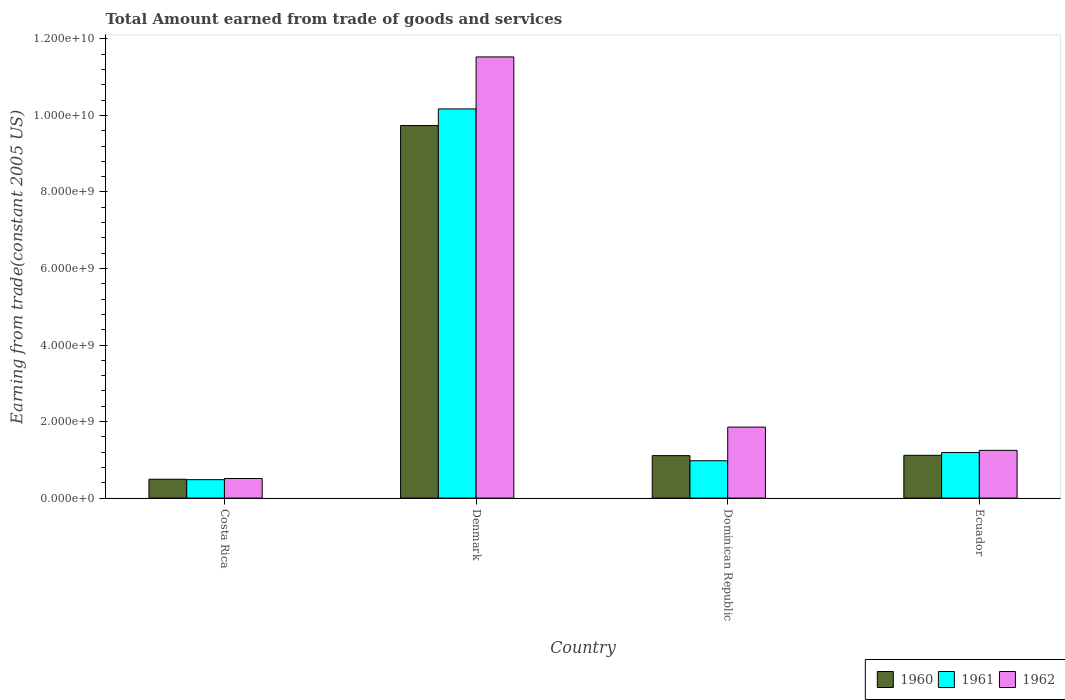How many different coloured bars are there?
Give a very brief answer. 3. Are the number of bars on each tick of the X-axis equal?
Your answer should be very brief. Yes. How many bars are there on the 2nd tick from the right?
Keep it short and to the point. 3. What is the total amount earned by trading goods and services in 1962 in Costa Rica?
Offer a terse response. 5.12e+08. Across all countries, what is the maximum total amount earned by trading goods and services in 1960?
Offer a terse response. 9.74e+09. Across all countries, what is the minimum total amount earned by trading goods and services in 1960?
Provide a succinct answer. 4.92e+08. What is the total total amount earned by trading goods and services in 1962 in the graph?
Ensure brevity in your answer.  1.51e+1. What is the difference between the total amount earned by trading goods and services in 1960 in Denmark and that in Ecuador?
Your response must be concise. 8.62e+09. What is the difference between the total amount earned by trading goods and services in 1960 in Ecuador and the total amount earned by trading goods and services in 1962 in Costa Rica?
Your answer should be very brief. 6.06e+08. What is the average total amount earned by trading goods and services in 1961 per country?
Your response must be concise. 3.20e+09. What is the difference between the total amount earned by trading goods and services of/in 1961 and total amount earned by trading goods and services of/in 1960 in Ecuador?
Provide a short and direct response. 7.24e+07. What is the ratio of the total amount earned by trading goods and services in 1960 in Dominican Republic to that in Ecuador?
Offer a terse response. 0.99. What is the difference between the highest and the second highest total amount earned by trading goods and services in 1962?
Keep it short and to the point. 9.67e+09. What is the difference between the highest and the lowest total amount earned by trading goods and services in 1960?
Provide a short and direct response. 9.24e+09. In how many countries, is the total amount earned by trading goods and services in 1962 greater than the average total amount earned by trading goods and services in 1962 taken over all countries?
Your answer should be very brief. 1. Is the sum of the total amount earned by trading goods and services in 1960 in Denmark and Ecuador greater than the maximum total amount earned by trading goods and services in 1962 across all countries?
Keep it short and to the point. No. What does the 1st bar from the right in Costa Rica represents?
Keep it short and to the point. 1962. Is it the case that in every country, the sum of the total amount earned by trading goods and services in 1962 and total amount earned by trading goods and services in 1961 is greater than the total amount earned by trading goods and services in 1960?
Ensure brevity in your answer.  Yes. How many countries are there in the graph?
Your response must be concise. 4. What is the difference between two consecutive major ticks on the Y-axis?
Your answer should be very brief. 2.00e+09. Does the graph contain grids?
Your response must be concise. No. How are the legend labels stacked?
Your answer should be compact. Horizontal. What is the title of the graph?
Your response must be concise. Total Amount earned from trade of goods and services. Does "2007" appear as one of the legend labels in the graph?
Give a very brief answer. No. What is the label or title of the X-axis?
Offer a very short reply. Country. What is the label or title of the Y-axis?
Your answer should be compact. Earning from trade(constant 2005 US). What is the Earning from trade(constant 2005 US) of 1960 in Costa Rica?
Your answer should be very brief. 4.92e+08. What is the Earning from trade(constant 2005 US) of 1961 in Costa Rica?
Provide a short and direct response. 4.81e+08. What is the Earning from trade(constant 2005 US) of 1962 in Costa Rica?
Make the answer very short. 5.12e+08. What is the Earning from trade(constant 2005 US) in 1960 in Denmark?
Make the answer very short. 9.74e+09. What is the Earning from trade(constant 2005 US) of 1961 in Denmark?
Keep it short and to the point. 1.02e+1. What is the Earning from trade(constant 2005 US) in 1962 in Denmark?
Give a very brief answer. 1.15e+1. What is the Earning from trade(constant 2005 US) of 1960 in Dominican Republic?
Give a very brief answer. 1.11e+09. What is the Earning from trade(constant 2005 US) of 1961 in Dominican Republic?
Make the answer very short. 9.76e+08. What is the Earning from trade(constant 2005 US) of 1962 in Dominican Republic?
Offer a very short reply. 1.86e+09. What is the Earning from trade(constant 2005 US) in 1960 in Ecuador?
Your response must be concise. 1.12e+09. What is the Earning from trade(constant 2005 US) of 1961 in Ecuador?
Your answer should be very brief. 1.19e+09. What is the Earning from trade(constant 2005 US) in 1962 in Ecuador?
Ensure brevity in your answer.  1.25e+09. Across all countries, what is the maximum Earning from trade(constant 2005 US) in 1960?
Offer a very short reply. 9.74e+09. Across all countries, what is the maximum Earning from trade(constant 2005 US) in 1961?
Offer a very short reply. 1.02e+1. Across all countries, what is the maximum Earning from trade(constant 2005 US) in 1962?
Your response must be concise. 1.15e+1. Across all countries, what is the minimum Earning from trade(constant 2005 US) in 1960?
Keep it short and to the point. 4.92e+08. Across all countries, what is the minimum Earning from trade(constant 2005 US) of 1961?
Offer a terse response. 4.81e+08. Across all countries, what is the minimum Earning from trade(constant 2005 US) in 1962?
Your answer should be very brief. 5.12e+08. What is the total Earning from trade(constant 2005 US) of 1960 in the graph?
Make the answer very short. 1.25e+1. What is the total Earning from trade(constant 2005 US) of 1961 in the graph?
Your answer should be compact. 1.28e+1. What is the total Earning from trade(constant 2005 US) of 1962 in the graph?
Your answer should be compact. 1.51e+1. What is the difference between the Earning from trade(constant 2005 US) in 1960 in Costa Rica and that in Denmark?
Ensure brevity in your answer.  -9.24e+09. What is the difference between the Earning from trade(constant 2005 US) of 1961 in Costa Rica and that in Denmark?
Offer a terse response. -9.69e+09. What is the difference between the Earning from trade(constant 2005 US) of 1962 in Costa Rica and that in Denmark?
Ensure brevity in your answer.  -1.10e+1. What is the difference between the Earning from trade(constant 2005 US) of 1960 in Costa Rica and that in Dominican Republic?
Provide a short and direct response. -6.17e+08. What is the difference between the Earning from trade(constant 2005 US) of 1961 in Costa Rica and that in Dominican Republic?
Offer a very short reply. -4.95e+08. What is the difference between the Earning from trade(constant 2005 US) in 1962 in Costa Rica and that in Dominican Republic?
Offer a very short reply. -1.34e+09. What is the difference between the Earning from trade(constant 2005 US) of 1960 in Costa Rica and that in Ecuador?
Provide a short and direct response. -6.26e+08. What is the difference between the Earning from trade(constant 2005 US) in 1961 in Costa Rica and that in Ecuador?
Offer a very short reply. -7.09e+08. What is the difference between the Earning from trade(constant 2005 US) of 1962 in Costa Rica and that in Ecuador?
Make the answer very short. -7.35e+08. What is the difference between the Earning from trade(constant 2005 US) of 1960 in Denmark and that in Dominican Republic?
Provide a short and direct response. 8.63e+09. What is the difference between the Earning from trade(constant 2005 US) in 1961 in Denmark and that in Dominican Republic?
Provide a succinct answer. 9.19e+09. What is the difference between the Earning from trade(constant 2005 US) in 1962 in Denmark and that in Dominican Republic?
Offer a terse response. 9.67e+09. What is the difference between the Earning from trade(constant 2005 US) in 1960 in Denmark and that in Ecuador?
Make the answer very short. 8.62e+09. What is the difference between the Earning from trade(constant 2005 US) in 1961 in Denmark and that in Ecuador?
Make the answer very short. 8.98e+09. What is the difference between the Earning from trade(constant 2005 US) of 1962 in Denmark and that in Ecuador?
Keep it short and to the point. 1.03e+1. What is the difference between the Earning from trade(constant 2005 US) of 1960 in Dominican Republic and that in Ecuador?
Give a very brief answer. -8.29e+06. What is the difference between the Earning from trade(constant 2005 US) in 1961 in Dominican Republic and that in Ecuador?
Ensure brevity in your answer.  -2.14e+08. What is the difference between the Earning from trade(constant 2005 US) in 1962 in Dominican Republic and that in Ecuador?
Your answer should be compact. 6.08e+08. What is the difference between the Earning from trade(constant 2005 US) of 1960 in Costa Rica and the Earning from trade(constant 2005 US) of 1961 in Denmark?
Your answer should be compact. -9.68e+09. What is the difference between the Earning from trade(constant 2005 US) of 1960 in Costa Rica and the Earning from trade(constant 2005 US) of 1962 in Denmark?
Provide a short and direct response. -1.10e+1. What is the difference between the Earning from trade(constant 2005 US) in 1961 in Costa Rica and the Earning from trade(constant 2005 US) in 1962 in Denmark?
Offer a terse response. -1.10e+1. What is the difference between the Earning from trade(constant 2005 US) of 1960 in Costa Rica and the Earning from trade(constant 2005 US) of 1961 in Dominican Republic?
Provide a succinct answer. -4.84e+08. What is the difference between the Earning from trade(constant 2005 US) in 1960 in Costa Rica and the Earning from trade(constant 2005 US) in 1962 in Dominican Republic?
Offer a very short reply. -1.36e+09. What is the difference between the Earning from trade(constant 2005 US) in 1961 in Costa Rica and the Earning from trade(constant 2005 US) in 1962 in Dominican Republic?
Make the answer very short. -1.37e+09. What is the difference between the Earning from trade(constant 2005 US) of 1960 in Costa Rica and the Earning from trade(constant 2005 US) of 1961 in Ecuador?
Provide a short and direct response. -6.98e+08. What is the difference between the Earning from trade(constant 2005 US) in 1960 in Costa Rica and the Earning from trade(constant 2005 US) in 1962 in Ecuador?
Your answer should be compact. -7.55e+08. What is the difference between the Earning from trade(constant 2005 US) of 1961 in Costa Rica and the Earning from trade(constant 2005 US) of 1962 in Ecuador?
Make the answer very short. -7.66e+08. What is the difference between the Earning from trade(constant 2005 US) of 1960 in Denmark and the Earning from trade(constant 2005 US) of 1961 in Dominican Republic?
Your answer should be compact. 8.76e+09. What is the difference between the Earning from trade(constant 2005 US) in 1960 in Denmark and the Earning from trade(constant 2005 US) in 1962 in Dominican Republic?
Ensure brevity in your answer.  7.88e+09. What is the difference between the Earning from trade(constant 2005 US) of 1961 in Denmark and the Earning from trade(constant 2005 US) of 1962 in Dominican Republic?
Give a very brief answer. 8.31e+09. What is the difference between the Earning from trade(constant 2005 US) in 1960 in Denmark and the Earning from trade(constant 2005 US) in 1961 in Ecuador?
Offer a very short reply. 8.55e+09. What is the difference between the Earning from trade(constant 2005 US) of 1960 in Denmark and the Earning from trade(constant 2005 US) of 1962 in Ecuador?
Give a very brief answer. 8.49e+09. What is the difference between the Earning from trade(constant 2005 US) of 1961 in Denmark and the Earning from trade(constant 2005 US) of 1962 in Ecuador?
Give a very brief answer. 8.92e+09. What is the difference between the Earning from trade(constant 2005 US) in 1960 in Dominican Republic and the Earning from trade(constant 2005 US) in 1961 in Ecuador?
Your response must be concise. -8.07e+07. What is the difference between the Earning from trade(constant 2005 US) of 1960 in Dominican Republic and the Earning from trade(constant 2005 US) of 1962 in Ecuador?
Offer a terse response. -1.37e+08. What is the difference between the Earning from trade(constant 2005 US) in 1961 in Dominican Republic and the Earning from trade(constant 2005 US) in 1962 in Ecuador?
Provide a short and direct response. -2.71e+08. What is the average Earning from trade(constant 2005 US) in 1960 per country?
Offer a very short reply. 3.11e+09. What is the average Earning from trade(constant 2005 US) in 1961 per country?
Ensure brevity in your answer.  3.20e+09. What is the average Earning from trade(constant 2005 US) of 1962 per country?
Provide a short and direct response. 3.79e+09. What is the difference between the Earning from trade(constant 2005 US) of 1960 and Earning from trade(constant 2005 US) of 1961 in Costa Rica?
Your answer should be very brief. 1.09e+07. What is the difference between the Earning from trade(constant 2005 US) of 1960 and Earning from trade(constant 2005 US) of 1962 in Costa Rica?
Ensure brevity in your answer.  -1.99e+07. What is the difference between the Earning from trade(constant 2005 US) in 1961 and Earning from trade(constant 2005 US) in 1962 in Costa Rica?
Ensure brevity in your answer.  -3.08e+07. What is the difference between the Earning from trade(constant 2005 US) of 1960 and Earning from trade(constant 2005 US) of 1961 in Denmark?
Make the answer very short. -4.33e+08. What is the difference between the Earning from trade(constant 2005 US) of 1960 and Earning from trade(constant 2005 US) of 1962 in Denmark?
Give a very brief answer. -1.79e+09. What is the difference between the Earning from trade(constant 2005 US) in 1961 and Earning from trade(constant 2005 US) in 1962 in Denmark?
Offer a terse response. -1.36e+09. What is the difference between the Earning from trade(constant 2005 US) in 1960 and Earning from trade(constant 2005 US) in 1961 in Dominican Republic?
Provide a short and direct response. 1.34e+08. What is the difference between the Earning from trade(constant 2005 US) of 1960 and Earning from trade(constant 2005 US) of 1962 in Dominican Republic?
Give a very brief answer. -7.45e+08. What is the difference between the Earning from trade(constant 2005 US) of 1961 and Earning from trade(constant 2005 US) of 1962 in Dominican Republic?
Your answer should be compact. -8.79e+08. What is the difference between the Earning from trade(constant 2005 US) in 1960 and Earning from trade(constant 2005 US) in 1961 in Ecuador?
Offer a very short reply. -7.24e+07. What is the difference between the Earning from trade(constant 2005 US) in 1960 and Earning from trade(constant 2005 US) in 1962 in Ecuador?
Your response must be concise. -1.29e+08. What is the difference between the Earning from trade(constant 2005 US) in 1961 and Earning from trade(constant 2005 US) in 1962 in Ecuador?
Keep it short and to the point. -5.67e+07. What is the ratio of the Earning from trade(constant 2005 US) of 1960 in Costa Rica to that in Denmark?
Offer a terse response. 0.05. What is the ratio of the Earning from trade(constant 2005 US) in 1961 in Costa Rica to that in Denmark?
Offer a very short reply. 0.05. What is the ratio of the Earning from trade(constant 2005 US) in 1962 in Costa Rica to that in Denmark?
Offer a very short reply. 0.04. What is the ratio of the Earning from trade(constant 2005 US) in 1960 in Costa Rica to that in Dominican Republic?
Give a very brief answer. 0.44. What is the ratio of the Earning from trade(constant 2005 US) in 1961 in Costa Rica to that in Dominican Republic?
Your answer should be compact. 0.49. What is the ratio of the Earning from trade(constant 2005 US) in 1962 in Costa Rica to that in Dominican Republic?
Offer a terse response. 0.28. What is the ratio of the Earning from trade(constant 2005 US) in 1960 in Costa Rica to that in Ecuador?
Provide a short and direct response. 0.44. What is the ratio of the Earning from trade(constant 2005 US) of 1961 in Costa Rica to that in Ecuador?
Give a very brief answer. 0.4. What is the ratio of the Earning from trade(constant 2005 US) of 1962 in Costa Rica to that in Ecuador?
Provide a short and direct response. 0.41. What is the ratio of the Earning from trade(constant 2005 US) of 1960 in Denmark to that in Dominican Republic?
Provide a short and direct response. 8.77. What is the ratio of the Earning from trade(constant 2005 US) in 1961 in Denmark to that in Dominican Republic?
Make the answer very short. 10.42. What is the ratio of the Earning from trade(constant 2005 US) in 1962 in Denmark to that in Dominican Republic?
Keep it short and to the point. 6.21. What is the ratio of the Earning from trade(constant 2005 US) in 1960 in Denmark to that in Ecuador?
Provide a short and direct response. 8.71. What is the ratio of the Earning from trade(constant 2005 US) of 1961 in Denmark to that in Ecuador?
Provide a short and direct response. 8.54. What is the ratio of the Earning from trade(constant 2005 US) in 1962 in Denmark to that in Ecuador?
Offer a terse response. 9.24. What is the ratio of the Earning from trade(constant 2005 US) of 1961 in Dominican Republic to that in Ecuador?
Offer a very short reply. 0.82. What is the ratio of the Earning from trade(constant 2005 US) of 1962 in Dominican Republic to that in Ecuador?
Make the answer very short. 1.49. What is the difference between the highest and the second highest Earning from trade(constant 2005 US) of 1960?
Provide a succinct answer. 8.62e+09. What is the difference between the highest and the second highest Earning from trade(constant 2005 US) of 1961?
Give a very brief answer. 8.98e+09. What is the difference between the highest and the second highest Earning from trade(constant 2005 US) in 1962?
Your answer should be very brief. 9.67e+09. What is the difference between the highest and the lowest Earning from trade(constant 2005 US) of 1960?
Offer a terse response. 9.24e+09. What is the difference between the highest and the lowest Earning from trade(constant 2005 US) in 1961?
Keep it short and to the point. 9.69e+09. What is the difference between the highest and the lowest Earning from trade(constant 2005 US) in 1962?
Give a very brief answer. 1.10e+1. 